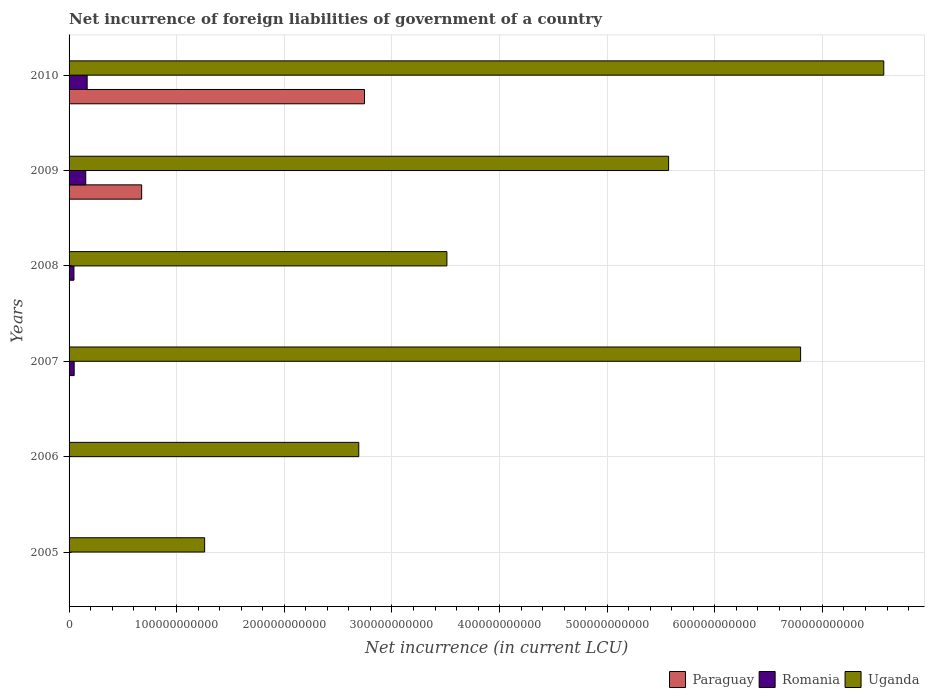Are the number of bars per tick equal to the number of legend labels?
Keep it short and to the point. No. Are the number of bars on each tick of the Y-axis equal?
Your answer should be very brief. No. How many bars are there on the 5th tick from the top?
Provide a succinct answer. 1. In how many cases, is the number of bars for a given year not equal to the number of legend labels?
Offer a very short reply. 4. What is the net incurrence of foreign liabilities in Paraguay in 2009?
Offer a terse response. 6.75e+1. Across all years, what is the maximum net incurrence of foreign liabilities in Uganda?
Your response must be concise. 7.57e+11. Across all years, what is the minimum net incurrence of foreign liabilities in Paraguay?
Your answer should be very brief. 0. What is the total net incurrence of foreign liabilities in Paraguay in the graph?
Offer a very short reply. 3.42e+11. What is the difference between the net incurrence of foreign liabilities in Romania in 2005 and that in 2009?
Offer a terse response. -1.52e+1. What is the difference between the net incurrence of foreign liabilities in Romania in 2010 and the net incurrence of foreign liabilities in Uganda in 2005?
Make the answer very short. -1.09e+11. What is the average net incurrence of foreign liabilities in Paraguay per year?
Your answer should be very brief. 5.70e+1. In the year 2008, what is the difference between the net incurrence of foreign liabilities in Romania and net incurrence of foreign liabilities in Uganda?
Your answer should be compact. -3.47e+11. In how many years, is the net incurrence of foreign liabilities in Romania greater than 280000000000 LCU?
Provide a succinct answer. 0. What is the ratio of the net incurrence of foreign liabilities in Uganda in 2005 to that in 2010?
Keep it short and to the point. 0.17. Is the difference between the net incurrence of foreign liabilities in Romania in 2005 and 2007 greater than the difference between the net incurrence of foreign liabilities in Uganda in 2005 and 2007?
Make the answer very short. Yes. What is the difference between the highest and the second highest net incurrence of foreign liabilities in Romania?
Provide a short and direct response. 1.31e+09. What is the difference between the highest and the lowest net incurrence of foreign liabilities in Paraguay?
Offer a terse response. 2.74e+11. In how many years, is the net incurrence of foreign liabilities in Paraguay greater than the average net incurrence of foreign liabilities in Paraguay taken over all years?
Keep it short and to the point. 2. Is the sum of the net incurrence of foreign liabilities in Uganda in 2008 and 2009 greater than the maximum net incurrence of foreign liabilities in Paraguay across all years?
Offer a terse response. Yes. How many bars are there?
Provide a short and direct response. 13. Are all the bars in the graph horizontal?
Provide a succinct answer. Yes. How many years are there in the graph?
Your answer should be very brief. 6. What is the difference between two consecutive major ticks on the X-axis?
Your answer should be compact. 1.00e+11. Are the values on the major ticks of X-axis written in scientific E-notation?
Your answer should be very brief. No. Does the graph contain any zero values?
Provide a short and direct response. Yes. Does the graph contain grids?
Keep it short and to the point. Yes. How are the legend labels stacked?
Your answer should be compact. Horizontal. What is the title of the graph?
Give a very brief answer. Net incurrence of foreign liabilities of government of a country. What is the label or title of the X-axis?
Ensure brevity in your answer.  Net incurrence (in current LCU). What is the label or title of the Y-axis?
Ensure brevity in your answer.  Years. What is the Net incurrence (in current LCU) of Romania in 2005?
Your answer should be compact. 3.37e+08. What is the Net incurrence (in current LCU) in Uganda in 2005?
Provide a short and direct response. 1.26e+11. What is the Net incurrence (in current LCU) of Paraguay in 2006?
Your answer should be very brief. 0. What is the Net incurrence (in current LCU) of Uganda in 2006?
Make the answer very short. 2.69e+11. What is the Net incurrence (in current LCU) of Paraguay in 2007?
Make the answer very short. 0. What is the Net incurrence (in current LCU) of Romania in 2007?
Your response must be concise. 4.74e+09. What is the Net incurrence (in current LCU) in Uganda in 2007?
Keep it short and to the point. 6.80e+11. What is the Net incurrence (in current LCU) of Romania in 2008?
Keep it short and to the point. 4.54e+09. What is the Net incurrence (in current LCU) in Uganda in 2008?
Offer a terse response. 3.51e+11. What is the Net incurrence (in current LCU) of Paraguay in 2009?
Offer a terse response. 6.75e+1. What is the Net incurrence (in current LCU) in Romania in 2009?
Give a very brief answer. 1.55e+1. What is the Net incurrence (in current LCU) in Uganda in 2009?
Give a very brief answer. 5.57e+11. What is the Net incurrence (in current LCU) of Paraguay in 2010?
Provide a short and direct response. 2.74e+11. What is the Net incurrence (in current LCU) in Romania in 2010?
Offer a terse response. 1.68e+1. What is the Net incurrence (in current LCU) of Uganda in 2010?
Make the answer very short. 7.57e+11. Across all years, what is the maximum Net incurrence (in current LCU) of Paraguay?
Ensure brevity in your answer.  2.74e+11. Across all years, what is the maximum Net incurrence (in current LCU) of Romania?
Offer a terse response. 1.68e+1. Across all years, what is the maximum Net incurrence (in current LCU) in Uganda?
Ensure brevity in your answer.  7.57e+11. Across all years, what is the minimum Net incurrence (in current LCU) in Uganda?
Ensure brevity in your answer.  1.26e+11. What is the total Net incurrence (in current LCU) in Paraguay in the graph?
Your answer should be very brief. 3.42e+11. What is the total Net incurrence (in current LCU) in Romania in the graph?
Ensure brevity in your answer.  4.19e+1. What is the total Net incurrence (in current LCU) of Uganda in the graph?
Ensure brevity in your answer.  2.74e+12. What is the difference between the Net incurrence (in current LCU) of Uganda in 2005 and that in 2006?
Offer a terse response. -1.43e+11. What is the difference between the Net incurrence (in current LCU) in Romania in 2005 and that in 2007?
Make the answer very short. -4.40e+09. What is the difference between the Net incurrence (in current LCU) of Uganda in 2005 and that in 2007?
Provide a succinct answer. -5.54e+11. What is the difference between the Net incurrence (in current LCU) in Romania in 2005 and that in 2008?
Offer a terse response. -4.20e+09. What is the difference between the Net incurrence (in current LCU) of Uganda in 2005 and that in 2008?
Ensure brevity in your answer.  -2.25e+11. What is the difference between the Net incurrence (in current LCU) of Romania in 2005 and that in 2009?
Give a very brief answer. -1.52e+1. What is the difference between the Net incurrence (in current LCU) of Uganda in 2005 and that in 2009?
Offer a terse response. -4.31e+11. What is the difference between the Net incurrence (in current LCU) of Romania in 2005 and that in 2010?
Give a very brief answer. -1.65e+1. What is the difference between the Net incurrence (in current LCU) in Uganda in 2005 and that in 2010?
Your response must be concise. -6.31e+11. What is the difference between the Net incurrence (in current LCU) of Uganda in 2006 and that in 2007?
Offer a very short reply. -4.11e+11. What is the difference between the Net incurrence (in current LCU) in Uganda in 2006 and that in 2008?
Offer a terse response. -8.19e+1. What is the difference between the Net incurrence (in current LCU) in Uganda in 2006 and that in 2009?
Keep it short and to the point. -2.88e+11. What is the difference between the Net incurrence (in current LCU) in Uganda in 2006 and that in 2010?
Offer a terse response. -4.88e+11. What is the difference between the Net incurrence (in current LCU) of Romania in 2007 and that in 2008?
Offer a terse response. 2.03e+08. What is the difference between the Net incurrence (in current LCU) in Uganda in 2007 and that in 2008?
Your answer should be compact. 3.29e+11. What is the difference between the Net incurrence (in current LCU) of Romania in 2007 and that in 2009?
Your answer should be compact. -1.08e+1. What is the difference between the Net incurrence (in current LCU) of Uganda in 2007 and that in 2009?
Keep it short and to the point. 1.23e+11. What is the difference between the Net incurrence (in current LCU) of Romania in 2007 and that in 2010?
Make the answer very short. -1.21e+1. What is the difference between the Net incurrence (in current LCU) in Uganda in 2007 and that in 2010?
Provide a succinct answer. -7.73e+1. What is the difference between the Net incurrence (in current LCU) of Romania in 2008 and that in 2009?
Ensure brevity in your answer.  -1.10e+1. What is the difference between the Net incurrence (in current LCU) in Uganda in 2008 and that in 2009?
Offer a terse response. -2.06e+11. What is the difference between the Net incurrence (in current LCU) of Romania in 2008 and that in 2010?
Offer a very short reply. -1.23e+1. What is the difference between the Net incurrence (in current LCU) in Uganda in 2008 and that in 2010?
Your response must be concise. -4.06e+11. What is the difference between the Net incurrence (in current LCU) of Paraguay in 2009 and that in 2010?
Ensure brevity in your answer.  -2.07e+11. What is the difference between the Net incurrence (in current LCU) in Romania in 2009 and that in 2010?
Offer a terse response. -1.31e+09. What is the difference between the Net incurrence (in current LCU) in Uganda in 2009 and that in 2010?
Offer a terse response. -2.00e+11. What is the difference between the Net incurrence (in current LCU) of Romania in 2005 and the Net incurrence (in current LCU) of Uganda in 2006?
Make the answer very short. -2.69e+11. What is the difference between the Net incurrence (in current LCU) in Romania in 2005 and the Net incurrence (in current LCU) in Uganda in 2007?
Offer a very short reply. -6.79e+11. What is the difference between the Net incurrence (in current LCU) of Romania in 2005 and the Net incurrence (in current LCU) of Uganda in 2008?
Provide a short and direct response. -3.51e+11. What is the difference between the Net incurrence (in current LCU) in Romania in 2005 and the Net incurrence (in current LCU) in Uganda in 2009?
Give a very brief answer. -5.57e+11. What is the difference between the Net incurrence (in current LCU) in Romania in 2005 and the Net incurrence (in current LCU) in Uganda in 2010?
Make the answer very short. -7.57e+11. What is the difference between the Net incurrence (in current LCU) of Romania in 2007 and the Net incurrence (in current LCU) of Uganda in 2008?
Offer a very short reply. -3.46e+11. What is the difference between the Net incurrence (in current LCU) in Romania in 2007 and the Net incurrence (in current LCU) in Uganda in 2009?
Make the answer very short. -5.52e+11. What is the difference between the Net incurrence (in current LCU) in Romania in 2007 and the Net incurrence (in current LCU) in Uganda in 2010?
Your answer should be compact. -7.52e+11. What is the difference between the Net incurrence (in current LCU) in Romania in 2008 and the Net incurrence (in current LCU) in Uganda in 2009?
Offer a very short reply. -5.53e+11. What is the difference between the Net incurrence (in current LCU) in Romania in 2008 and the Net incurrence (in current LCU) in Uganda in 2010?
Provide a succinct answer. -7.52e+11. What is the difference between the Net incurrence (in current LCU) of Paraguay in 2009 and the Net incurrence (in current LCU) of Romania in 2010?
Your response must be concise. 5.06e+1. What is the difference between the Net incurrence (in current LCU) in Paraguay in 2009 and the Net incurrence (in current LCU) in Uganda in 2010?
Ensure brevity in your answer.  -6.90e+11. What is the difference between the Net incurrence (in current LCU) in Romania in 2009 and the Net incurrence (in current LCU) in Uganda in 2010?
Your answer should be compact. -7.41e+11. What is the average Net incurrence (in current LCU) of Paraguay per year?
Provide a succinct answer. 5.70e+1. What is the average Net incurrence (in current LCU) of Romania per year?
Your response must be concise. 6.99e+09. What is the average Net incurrence (in current LCU) in Uganda per year?
Your answer should be very brief. 4.57e+11. In the year 2005, what is the difference between the Net incurrence (in current LCU) of Romania and Net incurrence (in current LCU) of Uganda?
Give a very brief answer. -1.26e+11. In the year 2007, what is the difference between the Net incurrence (in current LCU) in Romania and Net incurrence (in current LCU) in Uganda?
Give a very brief answer. -6.75e+11. In the year 2008, what is the difference between the Net incurrence (in current LCU) in Romania and Net incurrence (in current LCU) in Uganda?
Offer a very short reply. -3.47e+11. In the year 2009, what is the difference between the Net incurrence (in current LCU) of Paraguay and Net incurrence (in current LCU) of Romania?
Offer a very short reply. 5.20e+1. In the year 2009, what is the difference between the Net incurrence (in current LCU) in Paraguay and Net incurrence (in current LCU) in Uganda?
Make the answer very short. -4.90e+11. In the year 2009, what is the difference between the Net incurrence (in current LCU) in Romania and Net incurrence (in current LCU) in Uganda?
Your answer should be very brief. -5.42e+11. In the year 2010, what is the difference between the Net incurrence (in current LCU) in Paraguay and Net incurrence (in current LCU) in Romania?
Ensure brevity in your answer.  2.58e+11. In the year 2010, what is the difference between the Net incurrence (in current LCU) of Paraguay and Net incurrence (in current LCU) of Uganda?
Keep it short and to the point. -4.82e+11. In the year 2010, what is the difference between the Net incurrence (in current LCU) in Romania and Net incurrence (in current LCU) in Uganda?
Your response must be concise. -7.40e+11. What is the ratio of the Net incurrence (in current LCU) in Uganda in 2005 to that in 2006?
Offer a terse response. 0.47. What is the ratio of the Net incurrence (in current LCU) of Romania in 2005 to that in 2007?
Your answer should be compact. 0.07. What is the ratio of the Net incurrence (in current LCU) in Uganda in 2005 to that in 2007?
Offer a very short reply. 0.19. What is the ratio of the Net incurrence (in current LCU) of Romania in 2005 to that in 2008?
Provide a succinct answer. 0.07. What is the ratio of the Net incurrence (in current LCU) of Uganda in 2005 to that in 2008?
Ensure brevity in your answer.  0.36. What is the ratio of the Net incurrence (in current LCU) in Romania in 2005 to that in 2009?
Give a very brief answer. 0.02. What is the ratio of the Net incurrence (in current LCU) in Uganda in 2005 to that in 2009?
Give a very brief answer. 0.23. What is the ratio of the Net incurrence (in current LCU) in Uganda in 2005 to that in 2010?
Offer a very short reply. 0.17. What is the ratio of the Net incurrence (in current LCU) of Uganda in 2006 to that in 2007?
Provide a short and direct response. 0.4. What is the ratio of the Net incurrence (in current LCU) in Uganda in 2006 to that in 2008?
Give a very brief answer. 0.77. What is the ratio of the Net incurrence (in current LCU) in Uganda in 2006 to that in 2009?
Keep it short and to the point. 0.48. What is the ratio of the Net incurrence (in current LCU) of Uganda in 2006 to that in 2010?
Provide a succinct answer. 0.36. What is the ratio of the Net incurrence (in current LCU) of Romania in 2007 to that in 2008?
Keep it short and to the point. 1.04. What is the ratio of the Net incurrence (in current LCU) in Uganda in 2007 to that in 2008?
Your response must be concise. 1.94. What is the ratio of the Net incurrence (in current LCU) of Romania in 2007 to that in 2009?
Your answer should be very brief. 0.31. What is the ratio of the Net incurrence (in current LCU) of Uganda in 2007 to that in 2009?
Your answer should be compact. 1.22. What is the ratio of the Net incurrence (in current LCU) in Romania in 2007 to that in 2010?
Offer a terse response. 0.28. What is the ratio of the Net incurrence (in current LCU) of Uganda in 2007 to that in 2010?
Make the answer very short. 0.9. What is the ratio of the Net incurrence (in current LCU) in Romania in 2008 to that in 2009?
Your answer should be compact. 0.29. What is the ratio of the Net incurrence (in current LCU) in Uganda in 2008 to that in 2009?
Provide a succinct answer. 0.63. What is the ratio of the Net incurrence (in current LCU) of Romania in 2008 to that in 2010?
Your answer should be very brief. 0.27. What is the ratio of the Net incurrence (in current LCU) of Uganda in 2008 to that in 2010?
Your answer should be very brief. 0.46. What is the ratio of the Net incurrence (in current LCU) of Paraguay in 2009 to that in 2010?
Offer a very short reply. 0.25. What is the ratio of the Net incurrence (in current LCU) of Romania in 2009 to that in 2010?
Offer a very short reply. 0.92. What is the ratio of the Net incurrence (in current LCU) in Uganda in 2009 to that in 2010?
Your response must be concise. 0.74. What is the difference between the highest and the second highest Net incurrence (in current LCU) in Romania?
Provide a short and direct response. 1.31e+09. What is the difference between the highest and the second highest Net incurrence (in current LCU) in Uganda?
Make the answer very short. 7.73e+1. What is the difference between the highest and the lowest Net incurrence (in current LCU) in Paraguay?
Make the answer very short. 2.74e+11. What is the difference between the highest and the lowest Net incurrence (in current LCU) of Romania?
Offer a terse response. 1.68e+1. What is the difference between the highest and the lowest Net incurrence (in current LCU) of Uganda?
Provide a short and direct response. 6.31e+11. 